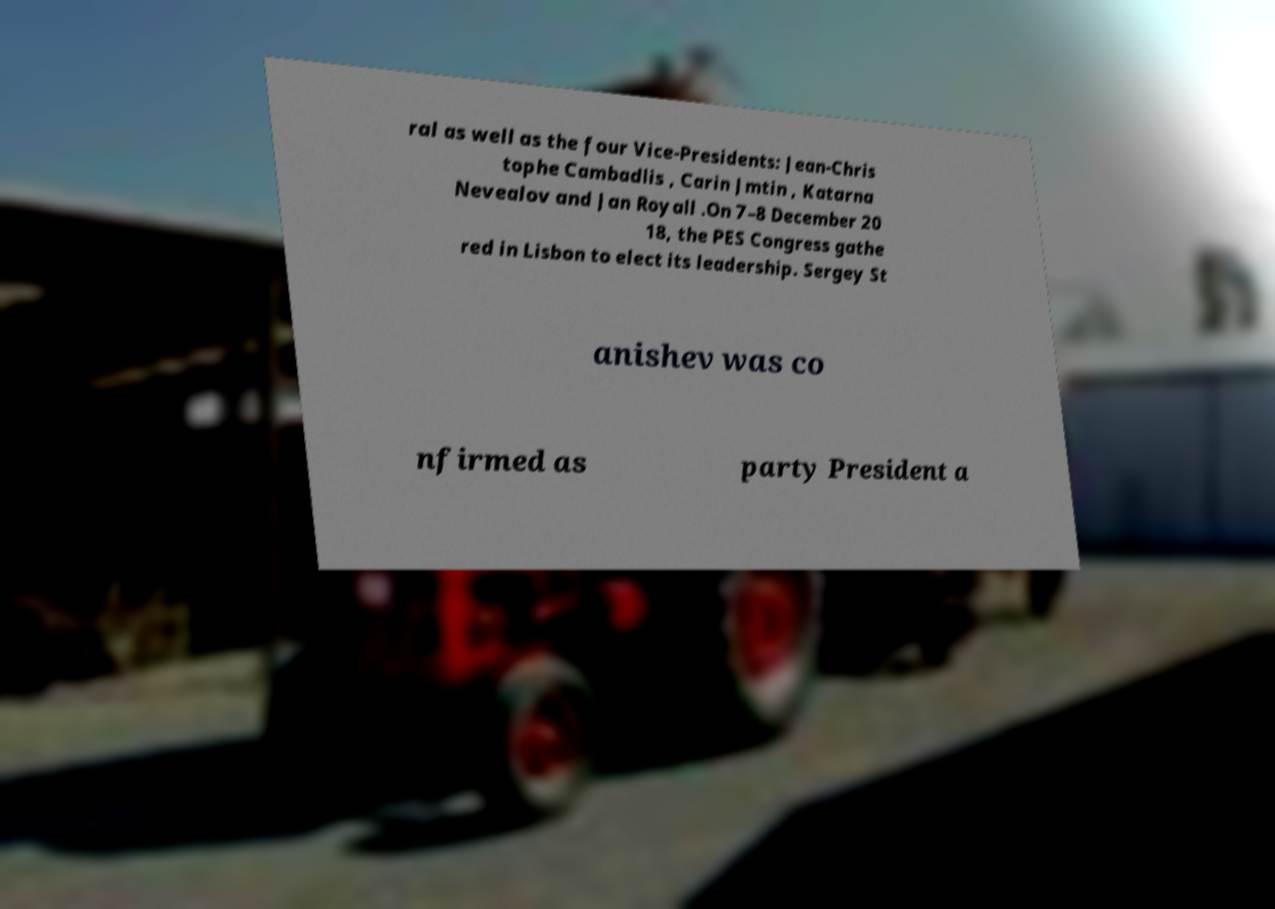Could you assist in decoding the text presented in this image and type it out clearly? ral as well as the four Vice-Presidents: Jean-Chris tophe Cambadlis , Carin Jmtin , Katarna Nevealov and Jan Royall .On 7–8 December 20 18, the PES Congress gathe red in Lisbon to elect its leadership. Sergey St anishev was co nfirmed as party President a 